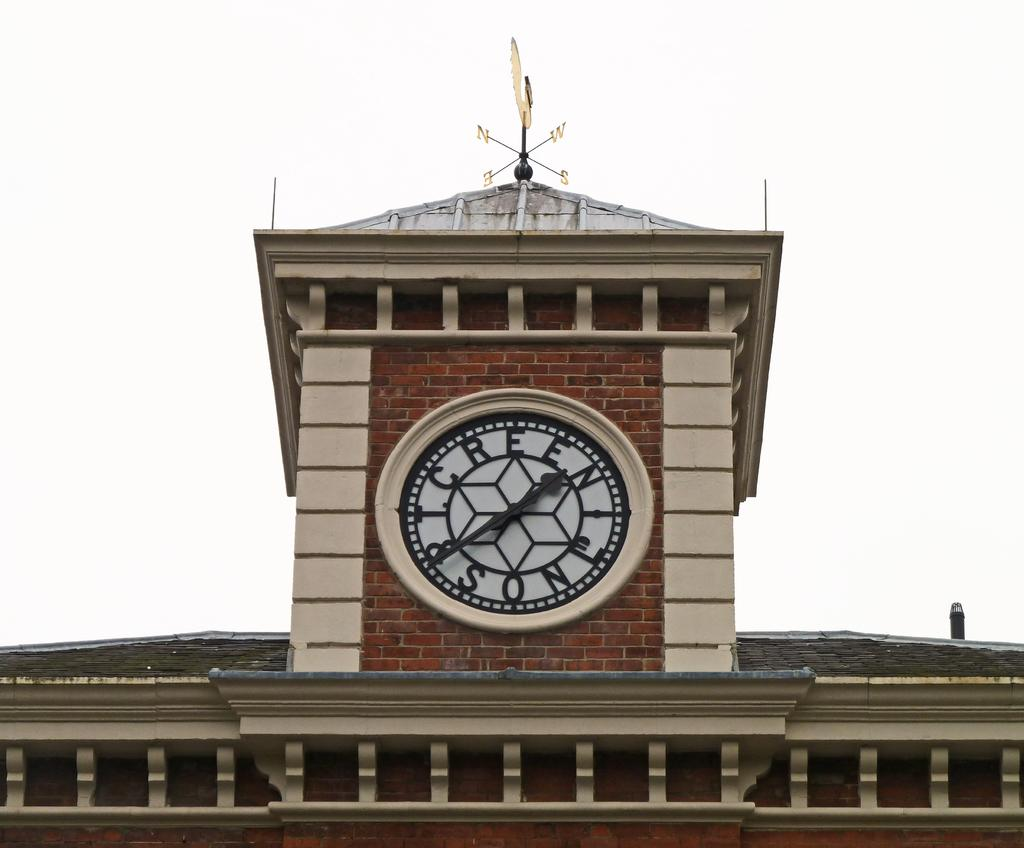<image>
Write a terse but informative summary of the picture. A large clock is built into a brick building, at the top with the words T. Creen & Son. 